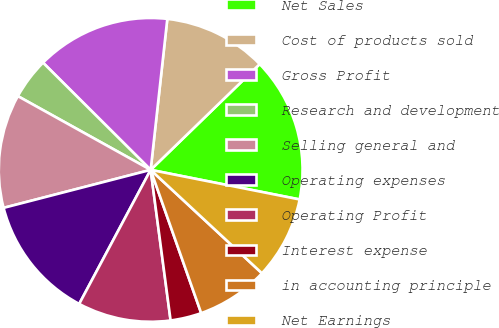Convert chart to OTSL. <chart><loc_0><loc_0><loc_500><loc_500><pie_chart><fcel>Net Sales<fcel>Cost of products sold<fcel>Gross Profit<fcel>Research and development<fcel>Selling general and<fcel>Operating expenses<fcel>Operating Profit<fcel>Interest expense<fcel>in accounting principle<fcel>Net Earnings<nl><fcel>15.38%<fcel>10.99%<fcel>14.28%<fcel>4.4%<fcel>12.09%<fcel>13.18%<fcel>9.89%<fcel>3.3%<fcel>7.69%<fcel>8.79%<nl></chart> 